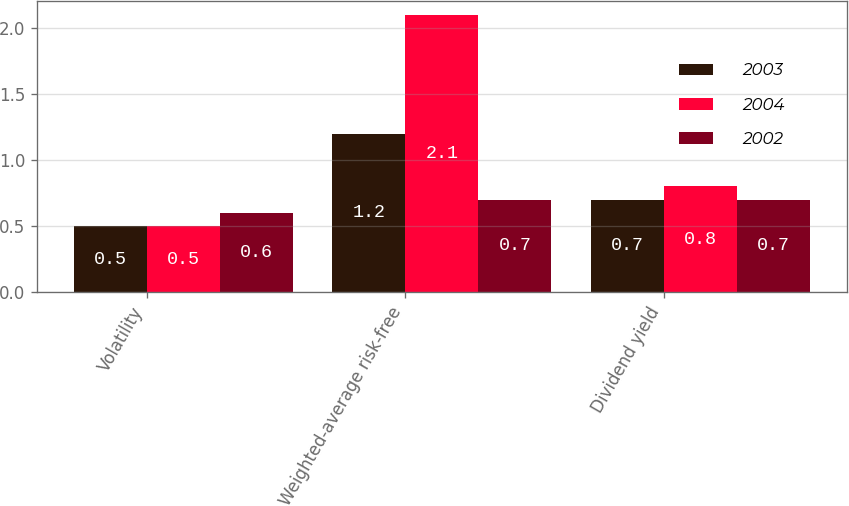<chart> <loc_0><loc_0><loc_500><loc_500><stacked_bar_chart><ecel><fcel>Volatility<fcel>Weighted-average risk-free<fcel>Dividend yield<nl><fcel>2003<fcel>0.5<fcel>1.2<fcel>0.7<nl><fcel>2004<fcel>0.5<fcel>2.1<fcel>0.8<nl><fcel>2002<fcel>0.6<fcel>0.7<fcel>0.7<nl></chart> 